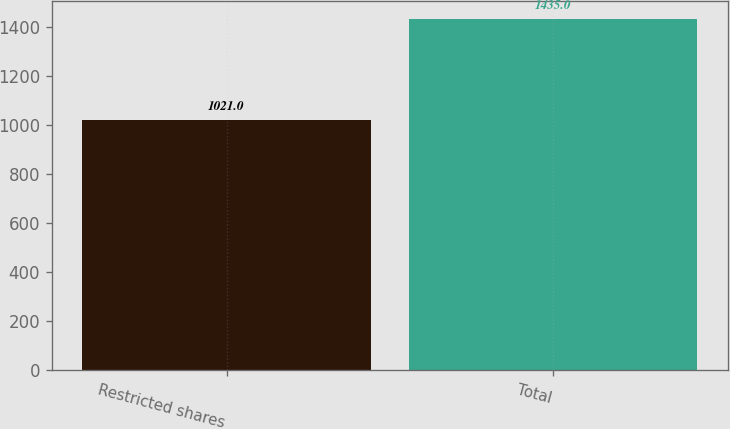Convert chart. <chart><loc_0><loc_0><loc_500><loc_500><bar_chart><fcel>Restricted shares<fcel>Total<nl><fcel>1021<fcel>1435<nl></chart> 